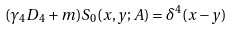<formula> <loc_0><loc_0><loc_500><loc_500>( \gamma _ { 4 } D _ { 4 } + m ) S _ { 0 } ( x , y ; A ) = \delta ^ { 4 } ( x - y )</formula> 